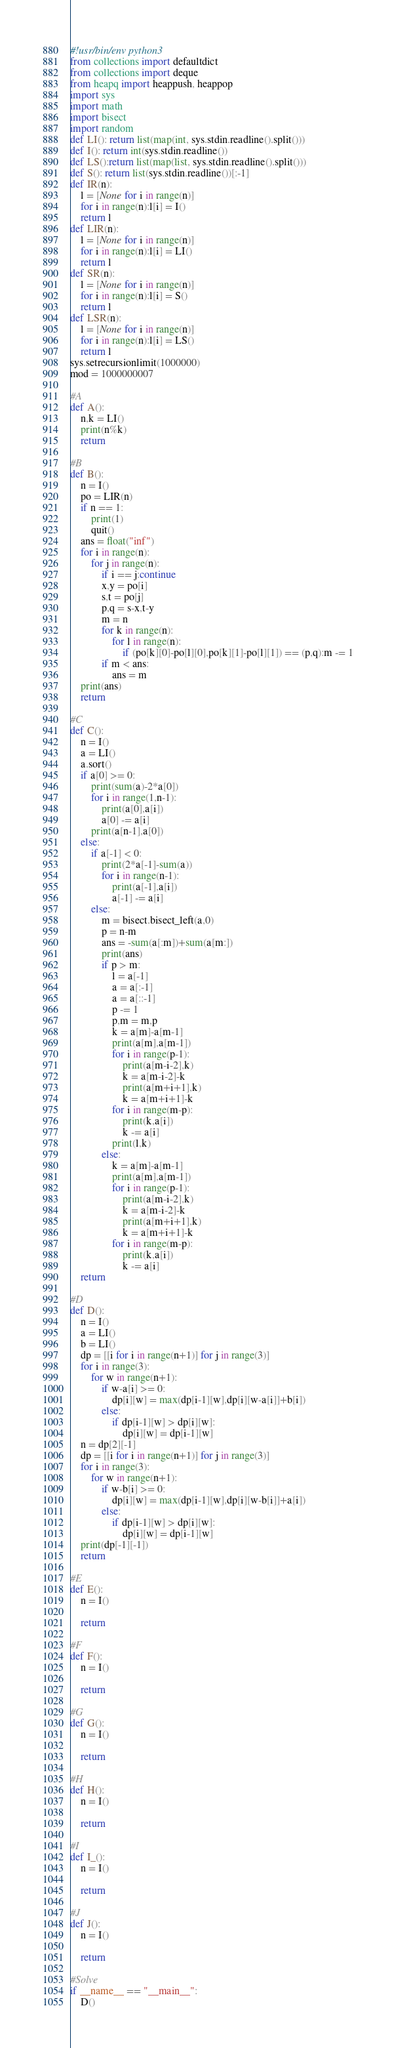Convert code to text. <code><loc_0><loc_0><loc_500><loc_500><_Python_>#!usr/bin/env python3
from collections import defaultdict
from collections import deque
from heapq import heappush, heappop
import sys
import math
import bisect
import random
def LI(): return list(map(int, sys.stdin.readline().split()))
def I(): return int(sys.stdin.readline())
def LS():return list(map(list, sys.stdin.readline().split()))
def S(): return list(sys.stdin.readline())[:-1]
def IR(n):
    l = [None for i in range(n)]
    for i in range(n):l[i] = I()
    return l
def LIR(n):
    l = [None for i in range(n)]
    for i in range(n):l[i] = LI()
    return l
def SR(n):
    l = [None for i in range(n)]
    for i in range(n):l[i] = S()
    return l
def LSR(n):
    l = [None for i in range(n)]
    for i in range(n):l[i] = LS()
    return l
sys.setrecursionlimit(1000000)
mod = 1000000007

#A
def A():
    n,k = LI()
    print(n%k)
    return

#B
def B():
    n = I()
    po = LIR(n)
    if n == 1:
        print(1)
        quit()
    ans = float("inf")
    for i in range(n):
        for j in range(n):
            if i == j:continue
            x,y = po[i]
            s,t = po[j]
            p,q = s-x,t-y
            m = n
            for k in range(n):
                for l in range(n):
                    if (po[k][0]-po[l][0],po[k][1]-po[l][1]) == (p,q):m -= 1
            if m < ans:
                ans = m
    print(ans)
    return

#C
def C():
    n = I()
    a = LI()
    a.sort()
    if a[0] >= 0:
        print(sum(a)-2*a[0])
        for i in range(1,n-1):
            print(a[0],a[i])
            a[0] -= a[i]
        print(a[n-1],a[0])
    else:
        if a[-1] < 0:
            print(2*a[-1]-sum(a))
            for i in range(n-1):
                print(a[-1],a[i])
                a[-1] -= a[i]
        else:
            m = bisect.bisect_left(a,0)
            p = n-m
            ans = -sum(a[:m])+sum(a[m:])
            print(ans)
            if p > m:
                l = a[-1]
                a = a[:-1]
                a = a[::-1]
                p -= 1
                p,m = m,p
                k = a[m]-a[m-1]
                print(a[m],a[m-1])
                for i in range(p-1):
                    print(a[m-i-2],k)
                    k = a[m-i-2]-k
                    print(a[m+i+1],k)
                    k = a[m+i+1]-k
                for i in range(m-p):
                    print(k,a[i])
                    k -= a[i]
                print(l,k)
            else:
                k = a[m]-a[m-1]
                print(a[m],a[m-1])
                for i in range(p-1):
                    print(a[m-i-2],k)
                    k = a[m-i-2]-k
                    print(a[m+i+1],k)
                    k = a[m+i+1]-k
                for i in range(m-p):
                    print(k,a[i])
                    k -= a[i]
    return

#D
def D():
    n = I()
    a = LI()
    b = LI()
    dp = [[i for i in range(n+1)] for j in range(3)]
    for i in range(3):
        for w in range(n+1):
            if w-a[i] >= 0:
                dp[i][w] = max(dp[i-1][w],dp[i][w-a[i]]+b[i])
            else:
                if dp[i-1][w] > dp[i][w]:
                    dp[i][w] = dp[i-1][w]
    n = dp[2][-1]
    dp = [[i for i in range(n+1)] for j in range(3)]
    for i in range(3):
        for w in range(n+1):
            if w-b[i] >= 0:
                dp[i][w] = max(dp[i-1][w],dp[i][w-b[i]]+a[i])
            else:
                if dp[i-1][w] > dp[i][w]:
                    dp[i][w] = dp[i-1][w]
    print(dp[-1][-1])
    return

#E
def E():
    n = I()

    return

#F
def F():
    n = I()

    return

#G
def G():
    n = I()

    return

#H
def H():
    n = I()

    return

#I
def I_():
    n = I()

    return

#J
def J():
    n = I()

    return

#Solve
if __name__ == "__main__":
    D()
</code> 